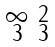Convert formula to latex. <formula><loc_0><loc_0><loc_500><loc_500>\begin{smallmatrix} \infty & 2 \\ 3 & 3 \end{smallmatrix}</formula> 